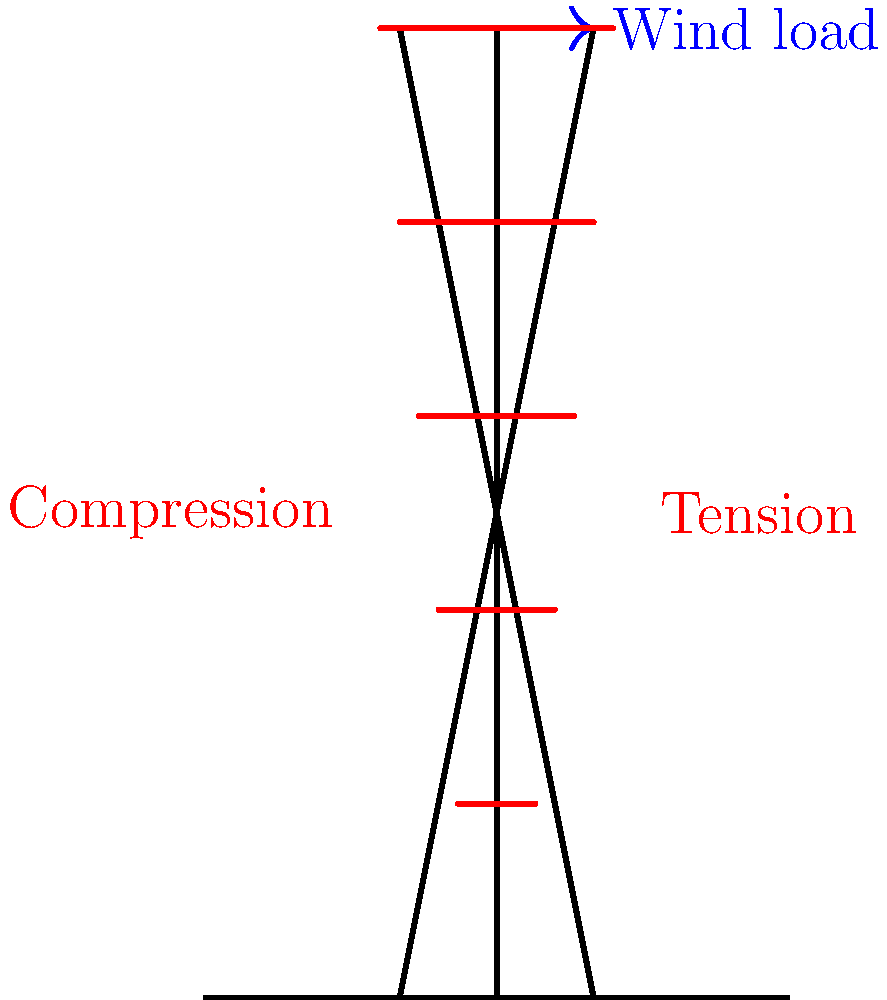As an investigative journalist researching the history of telecommunications, you come across a modern cell tower design. The diagram shows a simplified representation of a cell tower subjected to wind load. Based on the stress distribution indicated, what type of internal forces are likely to be experienced by the left leg of the tower structure? To answer this question, let's analyze the stress distribution in the cell tower structure step-by-step:

1. Wind load: The blue arrow at the top of the tower indicates a horizontal wind load acting from left to right.

2. Moment effect: This horizontal force creates a moment (rotational force) about the base of the tower, trying to topple it towards the right.

3. Resistance mechanism: To resist this toppling moment, the tower must develop internal forces in its legs.

4. Left leg analysis:
   a. The red stress indicators on the left side of the central axis are longer at the bottom and shorter at the top.
   b. This pattern indicates higher stress at the bottom, decreasing towards the top.
   c. The stress indicators are on the tower's left side, pointing towards the central axis.

5. Stress interpretation:
   a. When stress indicators point towards the member, it signifies compression.
   b. The left leg is experiencing compressive forces to counteract the wind-induced moment.

6. Physical explanation: As the wind tries to topple the tower to the right, the left leg must "push back" to maintain equilibrium, resulting in compression.

7. Right leg comparison: Although not asked in the question, it's worth noting that the right leg would experience tension for the same reason.

Therefore, based on the stress distribution shown in the diagram, the left leg of the cell tower structure is likely experiencing compressive internal forces.
Answer: Compressive forces 